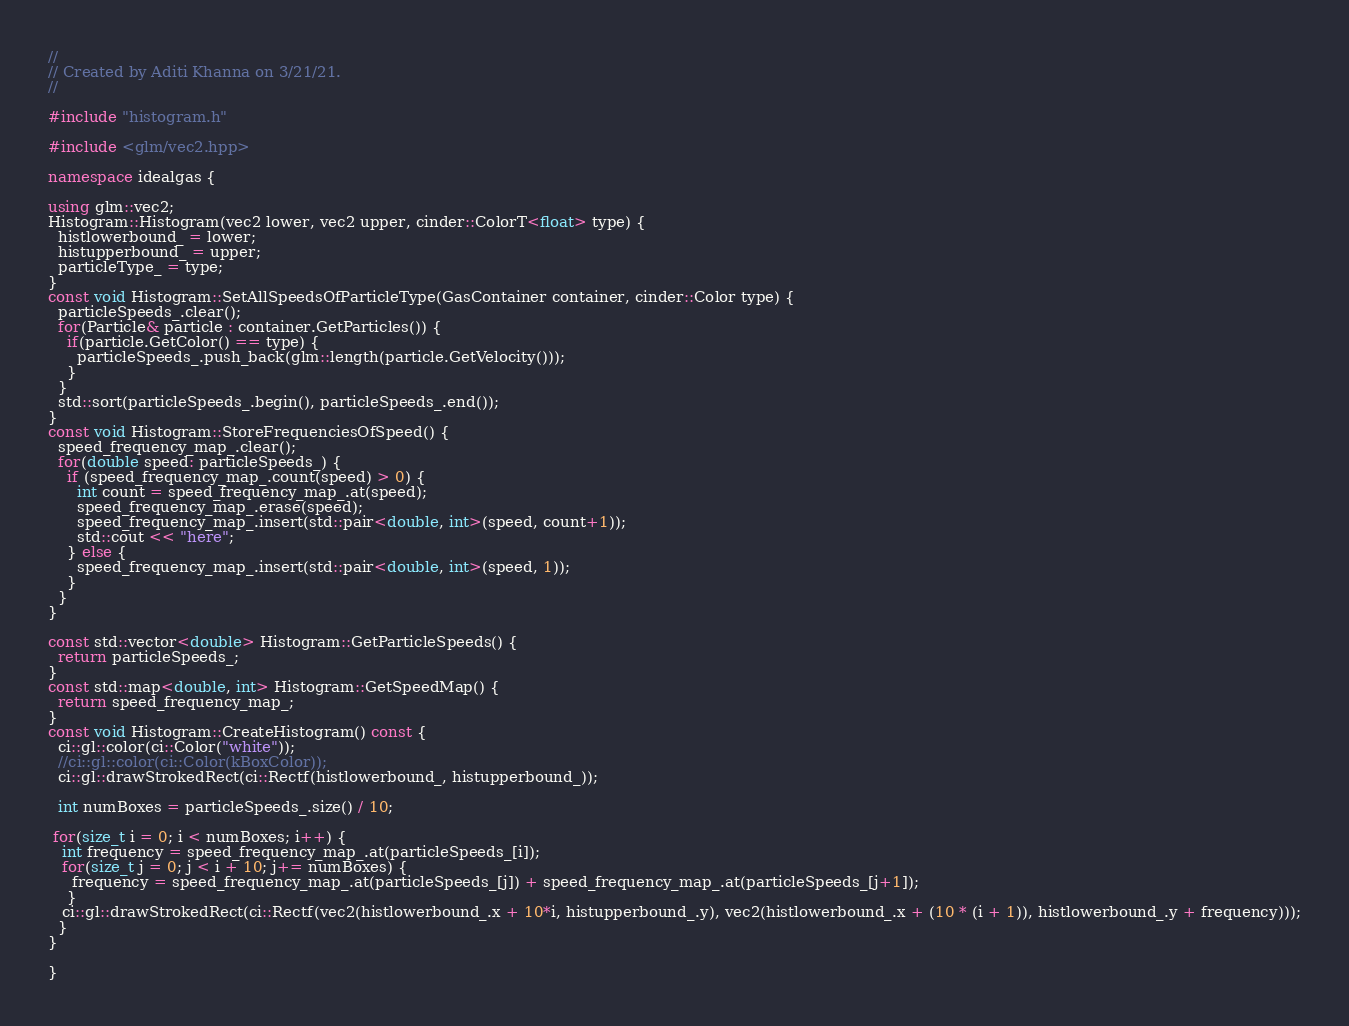Convert code to text. <code><loc_0><loc_0><loc_500><loc_500><_C++_>//
// Created by Aditi Khanna on 3/21/21.
//

#include "histogram.h"

#include <glm/vec2.hpp>

namespace idealgas {

using glm::vec2;
Histogram::Histogram(vec2 lower, vec2 upper, cinder::ColorT<float> type) {
  histlowerbound_ = lower;
  histupperbound_ = upper;
  particleType_ = type;
}
const void Histogram::SetAllSpeedsOfParticleType(GasContainer container, cinder::Color type) {
  particleSpeeds_.clear();
  for(Particle& particle : container.GetParticles()) {
    if(particle.GetColor() == type) {
      particleSpeeds_.push_back(glm::length(particle.GetVelocity()));
    }
  }
  std::sort(particleSpeeds_.begin(), particleSpeeds_.end());
}
const void Histogram::StoreFrequenciesOfSpeed() {
  speed_frequency_map_.clear();
  for(double speed: particleSpeeds_) {
    if (speed_frequency_map_.count(speed) > 0) {
      int count = speed_frequency_map_.at(speed);
      speed_frequency_map_.erase(speed);
      speed_frequency_map_.insert(std::pair<double, int>(speed, count+1));
      std::cout << "here";
    } else {
      speed_frequency_map_.insert(std::pair<double, int>(speed, 1));
    }
  }
}

const std::vector<double> Histogram::GetParticleSpeeds() {
  return particleSpeeds_;
}
const std::map<double, int> Histogram::GetSpeedMap() {
  return speed_frequency_map_;
}
const void Histogram::CreateHistogram() const {
  ci::gl::color(ci::Color("white"));
  //ci::gl::color(ci::Color(kBoxColor));
  ci::gl::drawStrokedRect(ci::Rectf(histlowerbound_, histupperbound_));

  int numBoxes = particleSpeeds_.size() / 10;

 for(size_t i = 0; i < numBoxes; i++) {
   int frequency = speed_frequency_map_.at(particleSpeeds_[i]);
   for(size_t j = 0; j < i + 10; j+= numBoxes) {
     frequency = speed_frequency_map_.at(particleSpeeds_[j]) + speed_frequency_map_.at(particleSpeeds_[j+1]);
    }
   ci::gl::drawStrokedRect(ci::Rectf(vec2(histlowerbound_.x + 10*i, histupperbound_.y), vec2(histlowerbound_.x + (10 * (i + 1)), histlowerbound_.y + frequency)));
  }
}

}</code> 